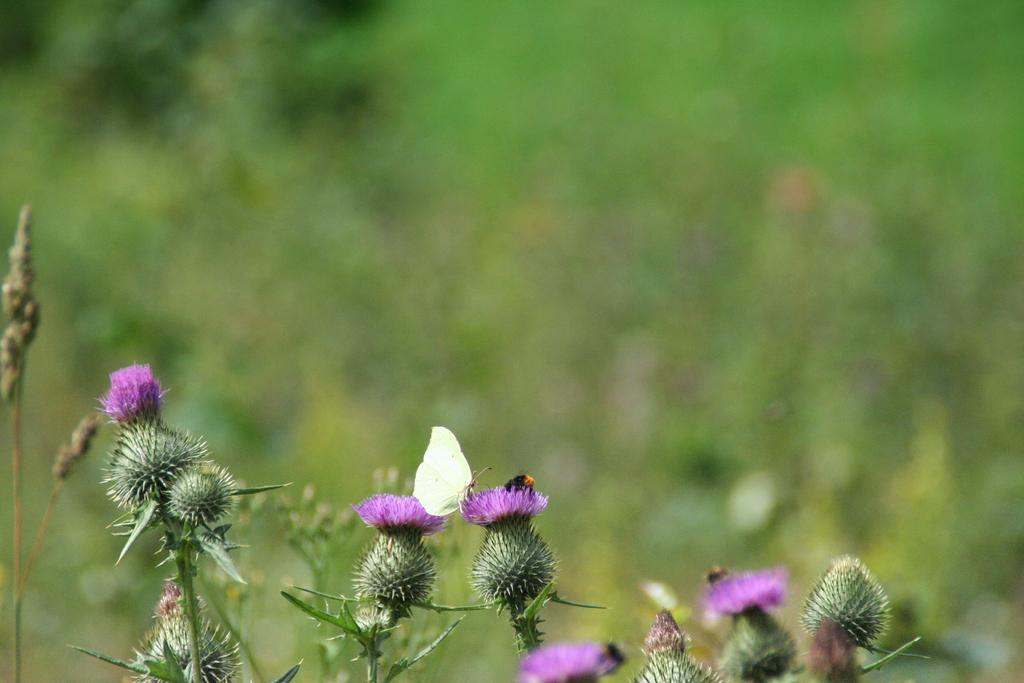What type of living organisms can be seen in the image? There are flowers and a butterfly in the image. What is the condition of the background in the image? The background of the image is blurred. What type of natural environment is visible in the image? There is greenery in the background of the image. What degree does the butterfly have in the image? Butterflies do not have degrees, as they are insects and not capable of obtaining academic qualifications. 